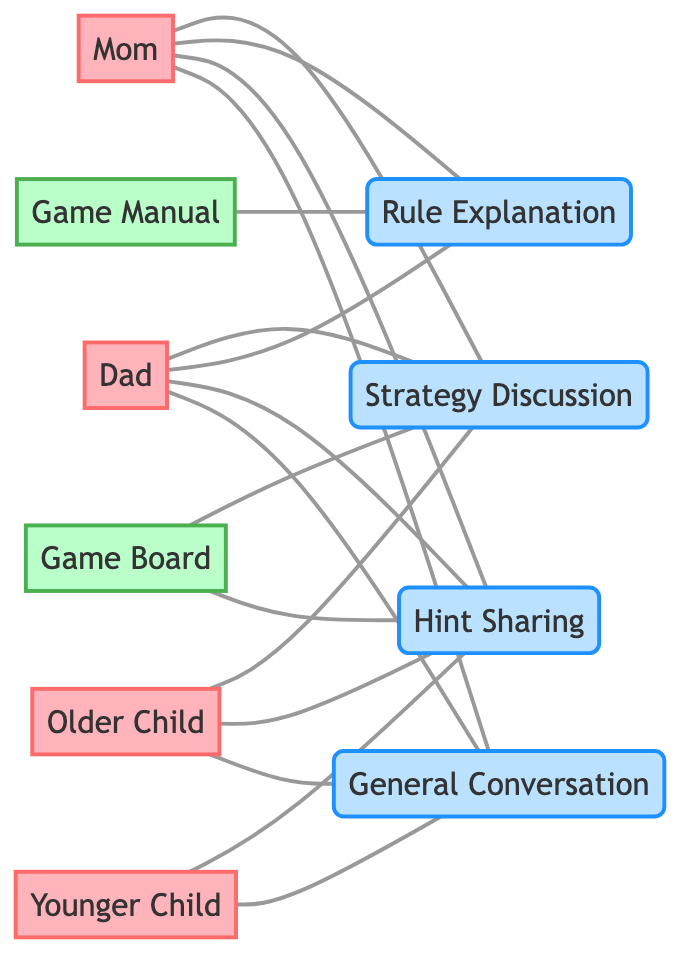What is the total number of people represented in the diagram? The diagram includes four people: Mom, Dad, Older Child, and Younger Child. Counting these elements gives a total of four individuals.
Answer: 4 Which communication channel connects Mom and Dad? Both Mom and Dad are connected through Strategy Discussion, Rule Explanation, Hint Sharing, and General Conversation. Since these are communication channels, they facilitate dialogue between them.
Answer: Strategy Discussion, Rule Explanation, Hint Sharing, General Conversation How many communication channels are depicted in the diagram? The diagram has four communication channels: Strategy Discussion, Rule Explanation, Hint Sharing, and General Conversation. By counting these elements, the answer is four.
Answer: 4 Who is associated with Hint Sharing? Hint Sharing is connected to Mom, Dad, and Older Child. Therefore, all three individuals share this channel of communication.
Answer: Mom, Dad, Older Child Which resource is connected to Rule Explanation? The resource linked to Rule Explanation is the Game Manual. This connection shows that the manual is used to clarify the game's rules.
Answer: Game Manual How many resources are shown in the diagram? The diagram contains two resources: Game Manual and Game Board. These are the only designated resources in the presented structure.
Answer: 2 Which child shares the most communication channels? The Older Child shares three communication channels: Strategy Discussion, Hint Sharing, and General Conversation. Comparing this with Younger Child, who only shares two channels, the answer is Older Child.
Answer: Older Child What type of communication is shared between both parents and children? The type of communication that is shared between both parents and children is General Conversation. This includes light discussion that can happen during game activities.
Answer: General Conversation What is the relationship between Game Board and Strategy Discussion? The Game Board is used in conjunction with Strategy Discussion. This means that during the game, the physical board resource facilitates strategic communication among family members.
Answer: Game Board 